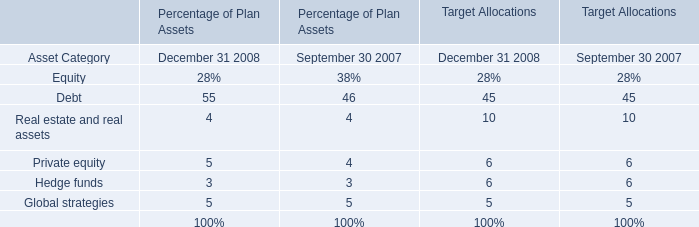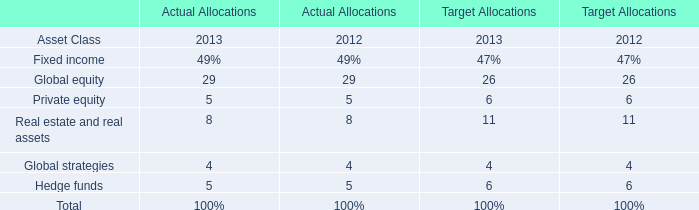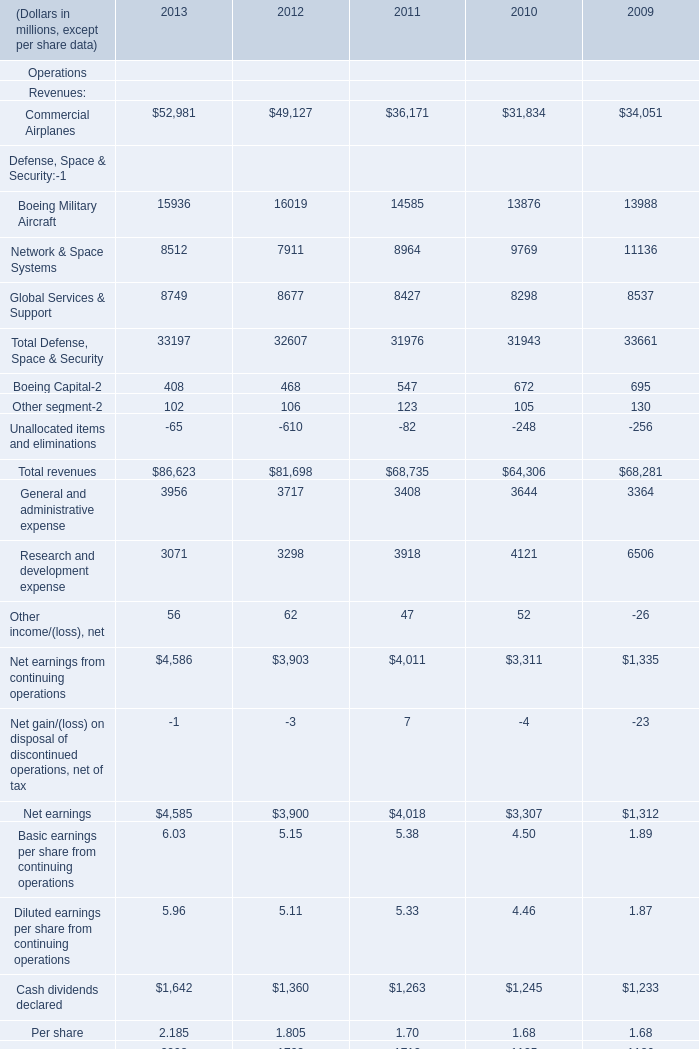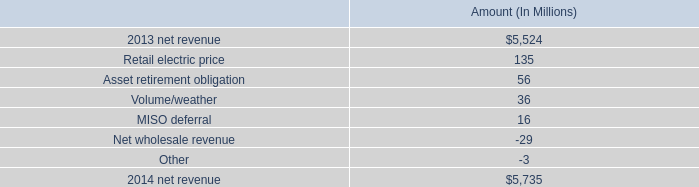What's the sum of the Boeing Military Aircraft for Defense, Space & Security:-1 in the years where Global equity for Actual Allocations is greater than 0? (in million) 
Computations: (15936 + 16019)
Answer: 31955.0. 